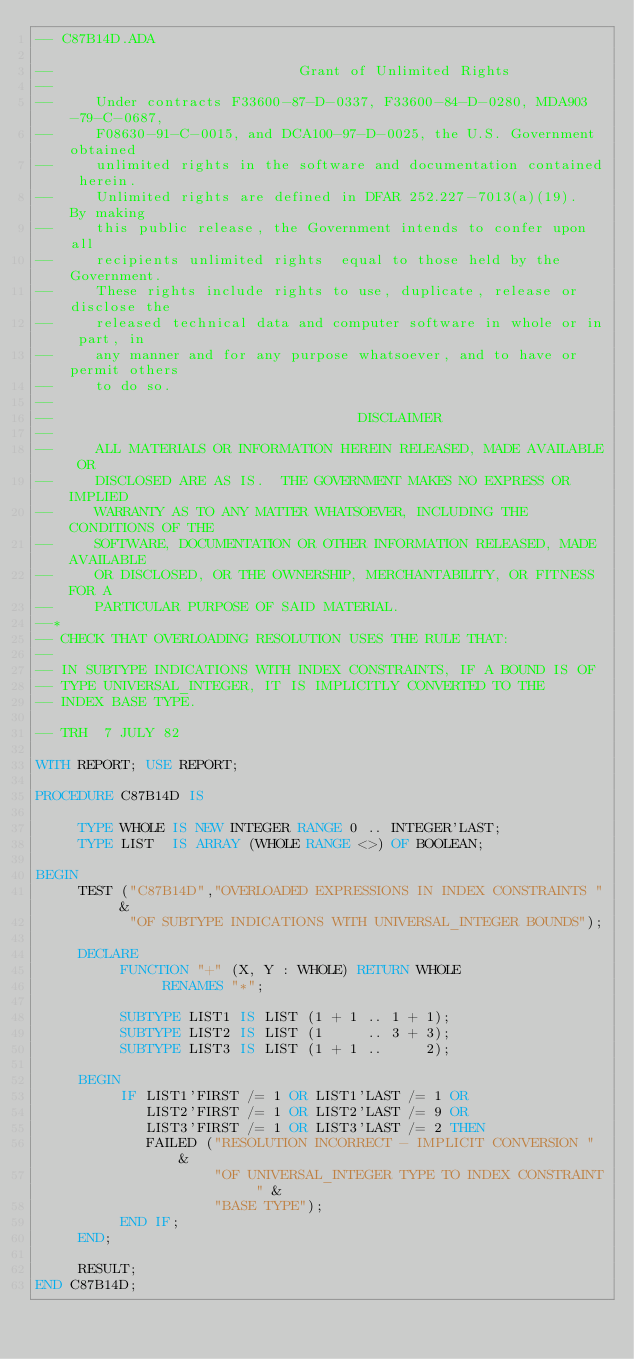<code> <loc_0><loc_0><loc_500><loc_500><_Ada_>-- C87B14D.ADA

--                             Grant of Unlimited Rights
--
--     Under contracts F33600-87-D-0337, F33600-84-D-0280, MDA903-79-C-0687,
--     F08630-91-C-0015, and DCA100-97-D-0025, the U.S. Government obtained 
--     unlimited rights in the software and documentation contained herein.
--     Unlimited rights are defined in DFAR 252.227-7013(a)(19).  By making 
--     this public release, the Government intends to confer upon all 
--     recipients unlimited rights  equal to those held by the Government.  
--     These rights include rights to use, duplicate, release or disclose the 
--     released technical data and computer software in whole or in part, in 
--     any manner and for any purpose whatsoever, and to have or permit others 
--     to do so.
--
--                                    DISCLAIMER
--
--     ALL MATERIALS OR INFORMATION HEREIN RELEASED, MADE AVAILABLE OR
--     DISCLOSED ARE AS IS.  THE GOVERNMENT MAKES NO EXPRESS OR IMPLIED 
--     WARRANTY AS TO ANY MATTER WHATSOEVER, INCLUDING THE CONDITIONS OF THE
--     SOFTWARE, DOCUMENTATION OR OTHER INFORMATION RELEASED, MADE AVAILABLE 
--     OR DISCLOSED, OR THE OWNERSHIP, MERCHANTABILITY, OR FITNESS FOR A
--     PARTICULAR PURPOSE OF SAID MATERIAL.
--*
-- CHECK THAT OVERLOADING RESOLUTION USES THE RULE THAT:
--
-- IN SUBTYPE INDICATIONS WITH INDEX CONSTRAINTS, IF A BOUND IS OF
-- TYPE UNIVERSAL_INTEGER, IT IS IMPLICITLY CONVERTED TO THE
-- INDEX BASE TYPE.
  
-- TRH  7 JULY 82
  
WITH REPORT; USE REPORT;
   
PROCEDURE C87B14D IS
     
     TYPE WHOLE IS NEW INTEGER RANGE 0 .. INTEGER'LAST;
     TYPE LIST  IS ARRAY (WHOLE RANGE <>) OF BOOLEAN;
  
BEGIN
     TEST ("C87B14D","OVERLOADED EXPRESSIONS IN INDEX CONSTRAINTS " &
           "OF SUBTYPE INDICATIONS WITH UNIVERSAL_INTEGER BOUNDS");
   
     DECLARE
          FUNCTION "+" (X, Y : WHOLE) RETURN WHOLE 
               RENAMES "*";
   
          SUBTYPE LIST1 IS LIST (1 + 1 .. 1 + 1);
          SUBTYPE LIST2 IS LIST (1     .. 3 + 3);
          SUBTYPE LIST3 IS LIST (1 + 1 ..     2);
  
     BEGIN
          IF LIST1'FIRST /= 1 OR LIST1'LAST /= 1 OR
             LIST2'FIRST /= 1 OR LIST2'LAST /= 9 OR
             LIST3'FIRST /= 1 OR LIST3'LAST /= 2 THEN 
             FAILED ("RESOLUTION INCORRECT - IMPLICIT CONVERSION " &
                     "OF UNIVERSAL_INTEGER TYPE TO INDEX CONSTRAINT " &
                     "BASE TYPE");
          END IF;
     END;
    
     RESULT;
END C87B14D;
</code> 